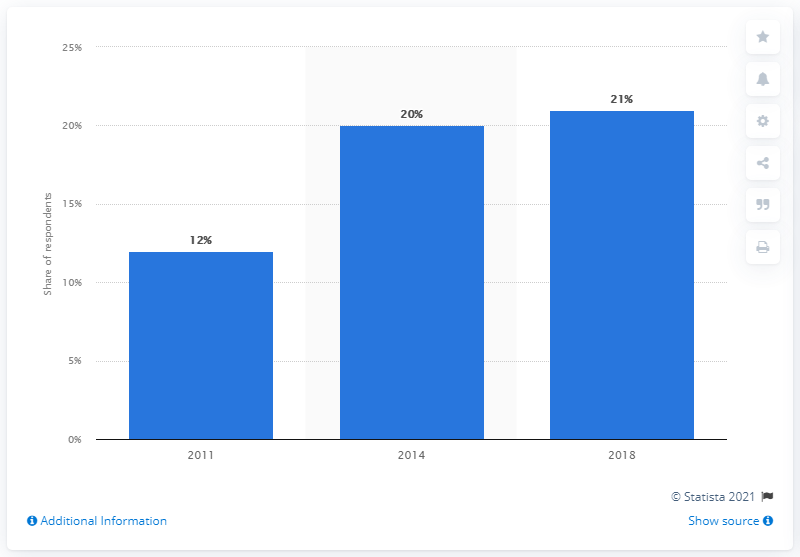List a handful of essential elements in this visual. A survey about the ownership rate of credit cards took place in Malaysia in 2011. 